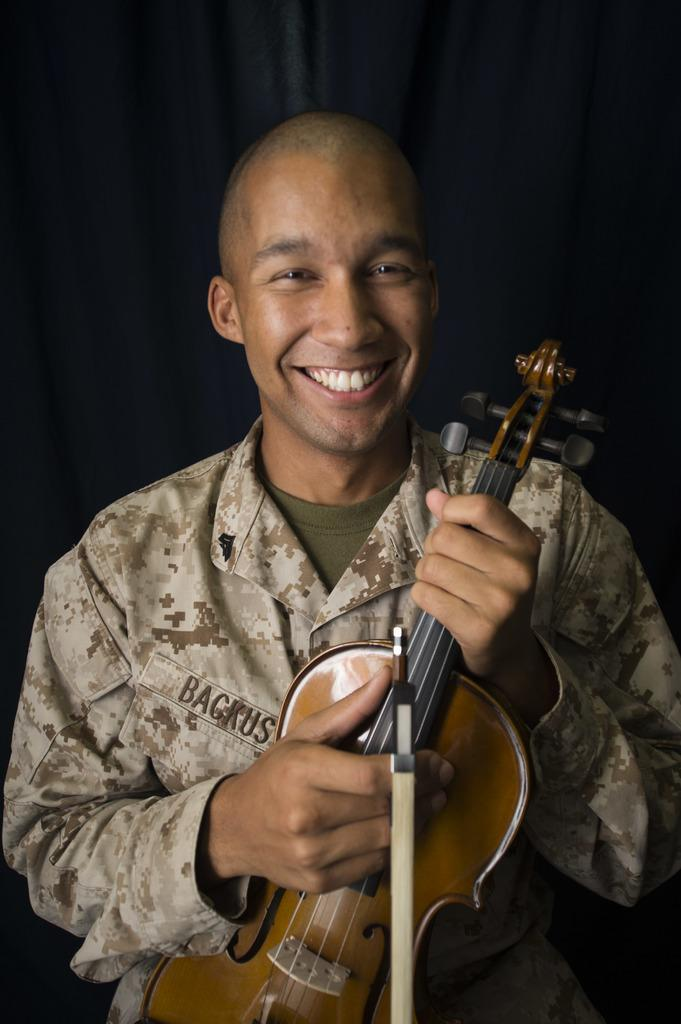Who is present in the image? There is a man in the image. What is the man doing in the image? The man is standing and holding a guitar. What is the man's facial expression in the image? The man is smiling in the image. What can be seen in the background of the image? There is a curtain in the background of the image. What is the man wearing in the image? The man is wearing a shirt with a design. What type of alarm is going off in the image? There is no alarm present in the image. What kind of feast is the man preparing in the image? There is no feast or cooking activity depicted in the image; the man is holding a guitar. 